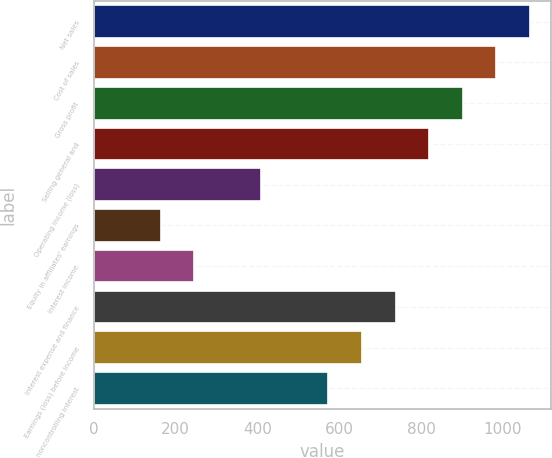<chart> <loc_0><loc_0><loc_500><loc_500><bar_chart><fcel>Net sales<fcel>Cost of sales<fcel>Gross profit<fcel>Selling general and<fcel>Operating income (loss)<fcel>Equity in affiliates' earnings<fcel>Interest income<fcel>Interest expense and finance<fcel>Earnings (loss) before income<fcel>noncontrolling interest<nl><fcel>1065.28<fcel>983.34<fcel>901.4<fcel>819.46<fcel>409.76<fcel>163.94<fcel>245.88<fcel>737.52<fcel>655.58<fcel>573.64<nl></chart> 